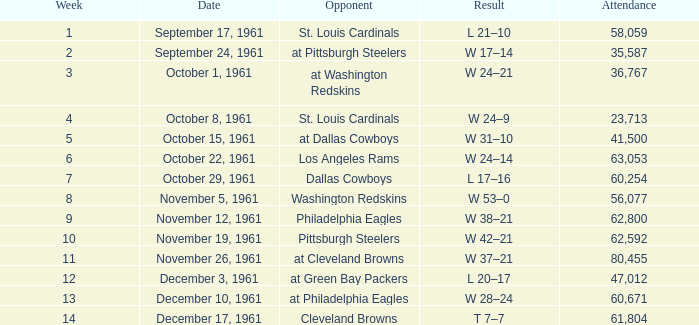What transpired on october 8, 1961? W 24–9. 